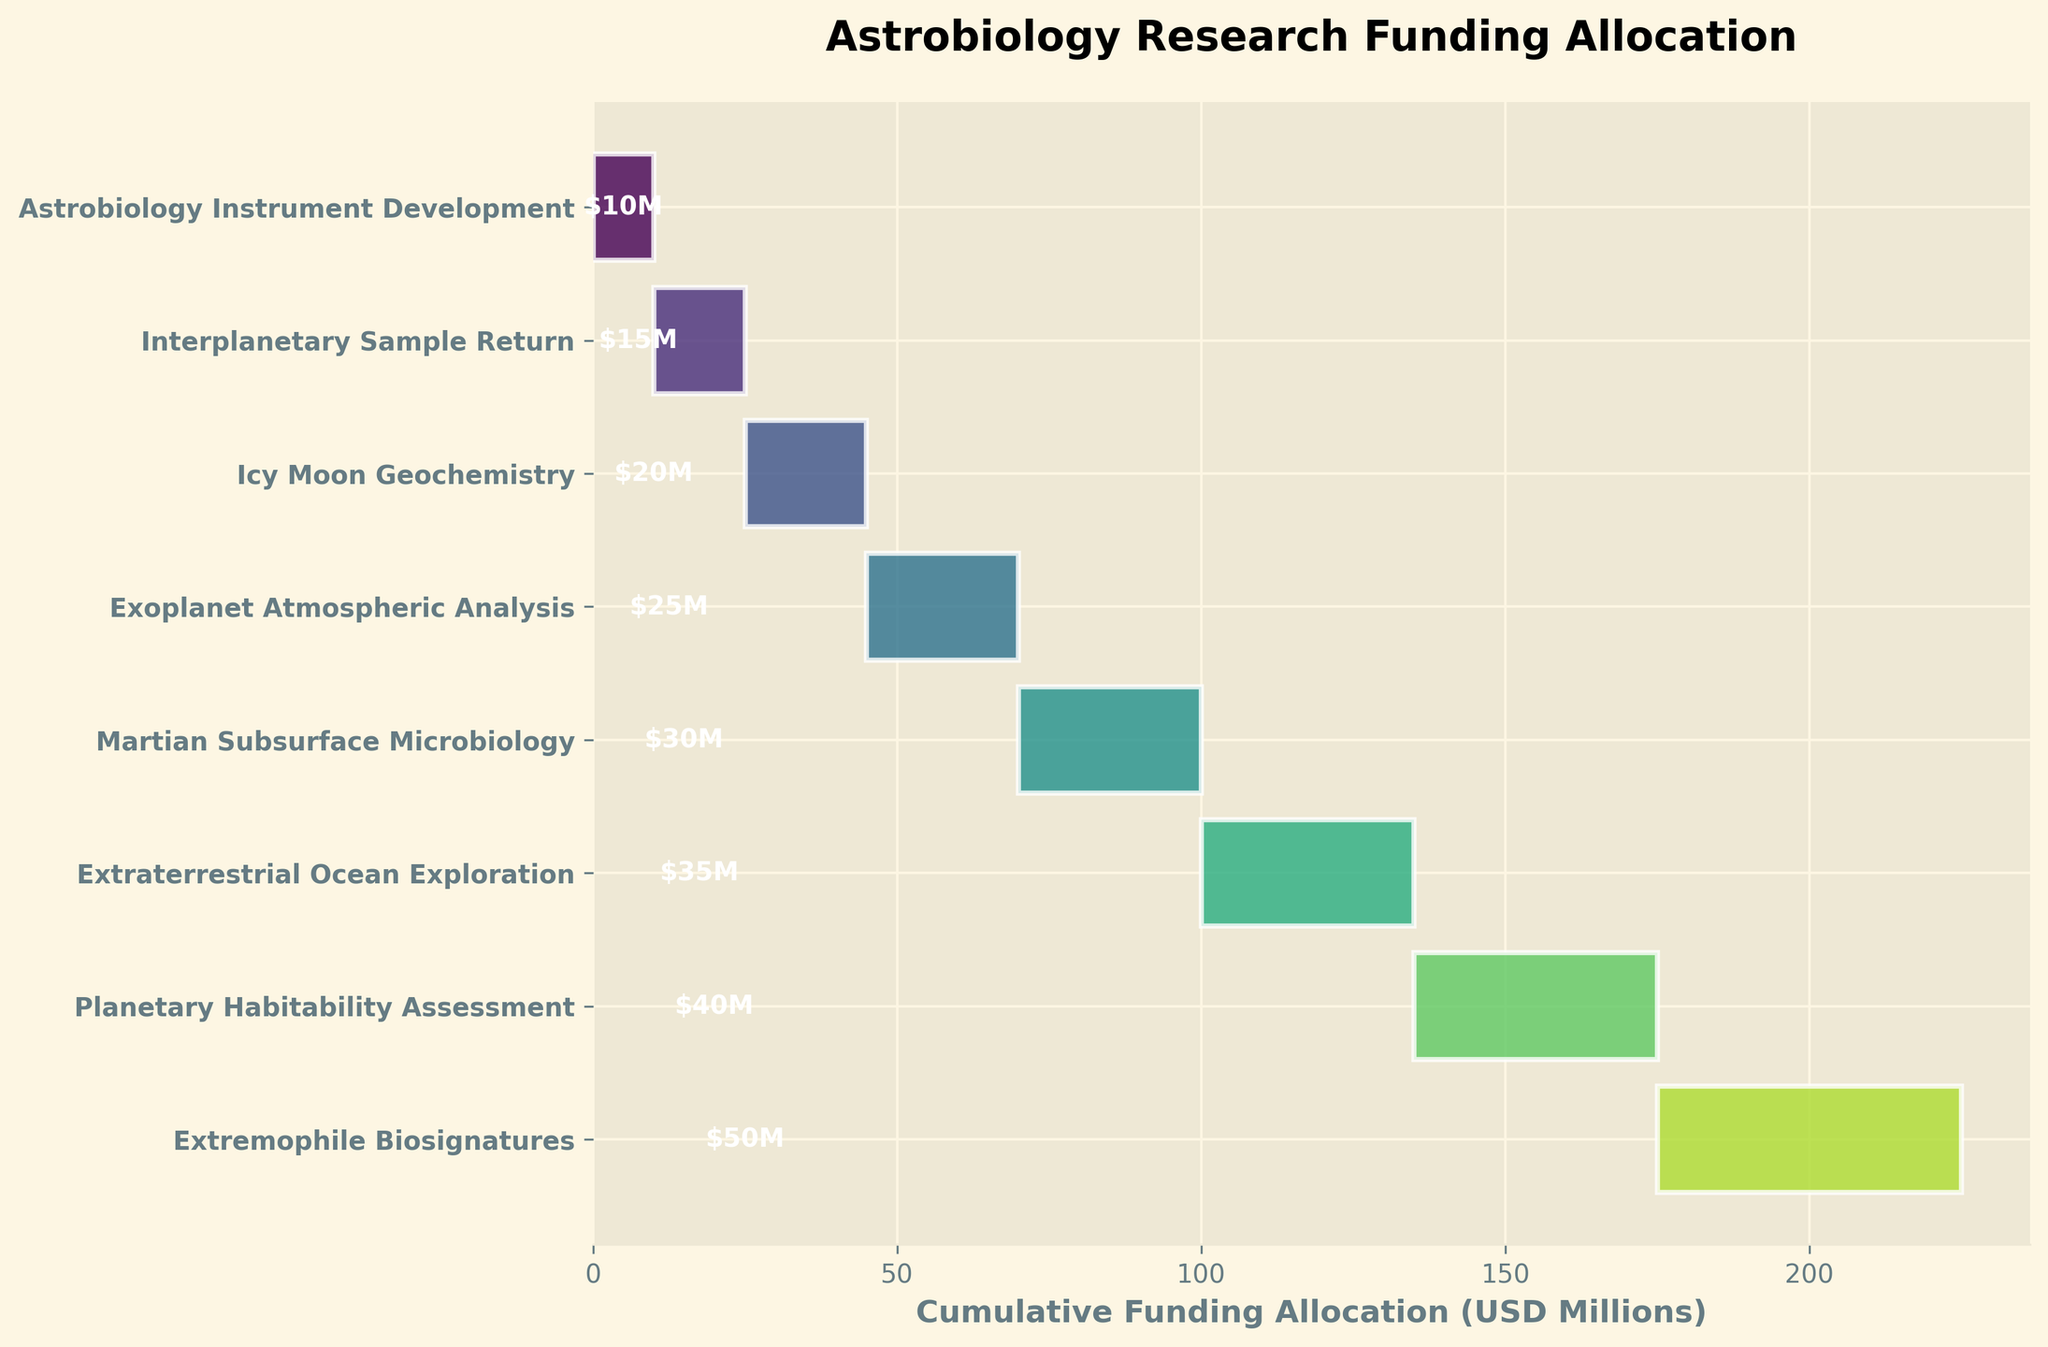What is the total funding allocated for Extremophile Biosignatures research? The figure shows that the funding allocation for Extremophile Biosignatures is $50 million.
Answer: $50 million What is the research focus with the second-highest funding allocation? The figure displays that the second-highest funding is for Planetary Habitability Assessment, allocated $40 million.
Answer: Planetary Habitability Assessment What is the difference in funding between Extraterrestrial Ocean Exploration and Martian Subsurface Microbiology? Extraterrestrial Ocean Exploration is allocated $35 million, while Martian Subsurface Microbiology is allocated $30 million. The difference is $35 million - $30 million = $5 million.
Answer: $5 million Which research area has the least amount of funding? The figure shows that Astrobiology Instrument Development has the least funding, with $10 million allocated.
Answer: Astrobiology Instrument Development What is the cumulative funding for the top three research focuses? The top three research focuses are Extremophile Biosignatures ($50 million), Planetary Habitability Assessment ($40 million), and Extraterrestrial Ocean Exploration ($35 million). The cumulative funding is $50 million + $40 million + $35 million = $125 million.
Answer: $125 million How does the funding for Exoplanet Atmospheric Analysis compare to that for Icy Moon Geochemistry? The funding for Exoplanet Atmospheric Analysis is $25 million, while the funding for Icy Moon Geochemistry is $20 million. Exoplanet Atmospheric Analysis has $5 million more.
Answer: $5 million more What percentage of the total funding goes to Interplanetary Sample Return? The total funding is $50 million + $40 million + $35 million + $30 million + $25 million + $20 million + $15 million + $10 million = $225 million. Interplanetary Sample Return is allocated $15 million. The percentage is ($15 million / $225 million) * 100% = 6.67%.
Answer: 6.67% How many research focuses have funding greater than $25 million? The research focuses with funding greater than $25 million are Extremophile Biosignatures ($50 million), Planetary Habitability Assessment ($40 million), Extraterrestrial Ocean Exploration ($35 million), and Martian Subsurface Microbiology ($30 million), which is four focuses.
Answer: Four What's the cumulative funding for Martian Subsurface Microbiology and Icy Moon Geochemistry? The funding for Martian Subsurface Microbiology is $30 million and for Icy Moon Geochemistry is $20 million. The cumulative funding is $30 million + $20 million = $50 million.
Answer: $50 million 